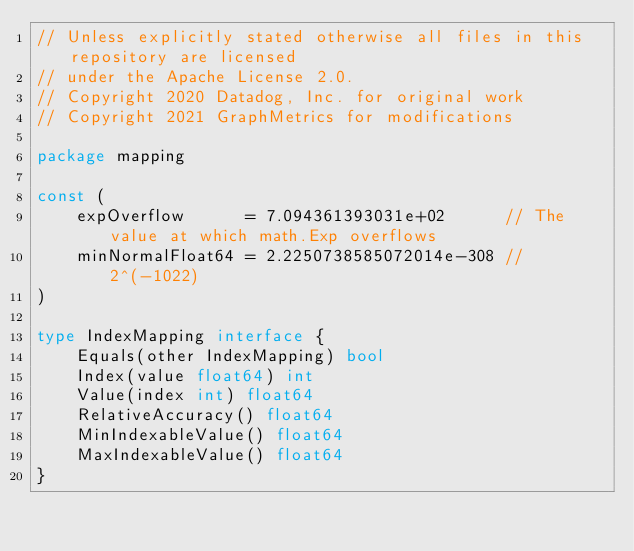Convert code to text. <code><loc_0><loc_0><loc_500><loc_500><_Go_>// Unless explicitly stated otherwise all files in this repository are licensed
// under the Apache License 2.0.
// Copyright 2020 Datadog, Inc. for original work
// Copyright 2021 GraphMetrics for modifications

package mapping

const (
	expOverflow      = 7.094361393031e+02      // The value at which math.Exp overflows
	minNormalFloat64 = 2.2250738585072014e-308 //2^(-1022)
)

type IndexMapping interface {
	Equals(other IndexMapping) bool
	Index(value float64) int
	Value(index int) float64
	RelativeAccuracy() float64
	MinIndexableValue() float64
	MaxIndexableValue() float64
}
</code> 